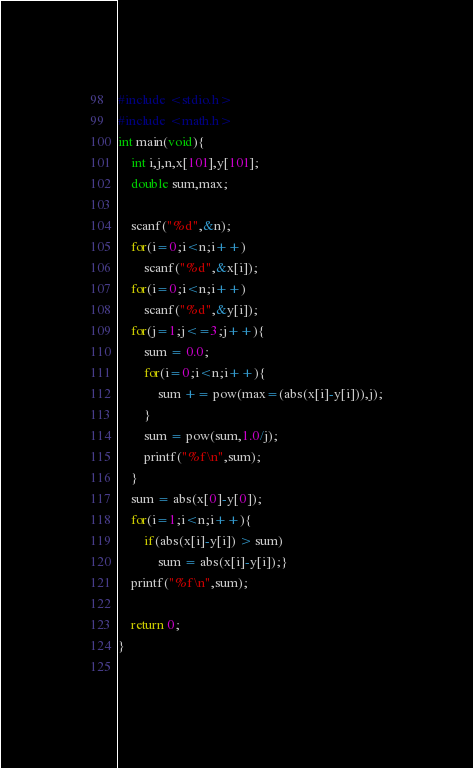Convert code to text. <code><loc_0><loc_0><loc_500><loc_500><_C_>#include <stdio.h>
#include <math.h>
int main(void){
	int i,j,n,x[101],y[101];
	double sum,max;

	scanf("%d",&n);
	for(i=0;i<n;i++)
		scanf("%d",&x[i]);
	for(i=0;i<n;i++)
		scanf("%d",&y[i]);
	for(j=1;j<=3;j++){
		sum = 0.0;
		for(i=0;i<n;i++){
			sum += pow(max=(abs(x[i]-y[i])),j);
		}
		sum = pow(sum,1.0/j);
		printf("%f\n",sum);
	}
	sum = abs(x[0]-y[0]);
	for(i=1;i<n;i++){
		if(abs(x[i]-y[i]) > sum)
			sum = abs(x[i]-y[i]);}		
	printf("%f\n",sum);

	return 0;
}
		</code> 